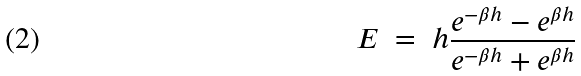Convert formula to latex. <formula><loc_0><loc_0><loc_500><loc_500>E \ = \ h \frac { e ^ { - \beta h } - e ^ { \beta h } } { e ^ { - \beta h } + e ^ { \beta h } } \</formula> 